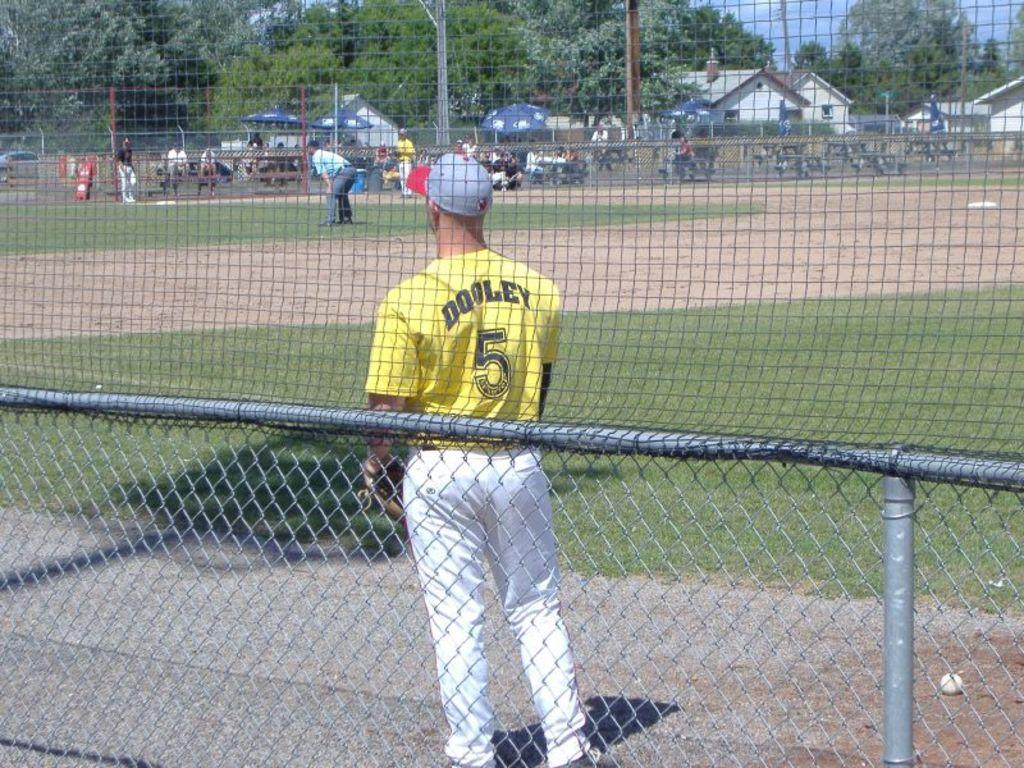<image>
Summarize the visual content of the image. Baseball player Dooley is wearing the yellow number 5 shirt. 